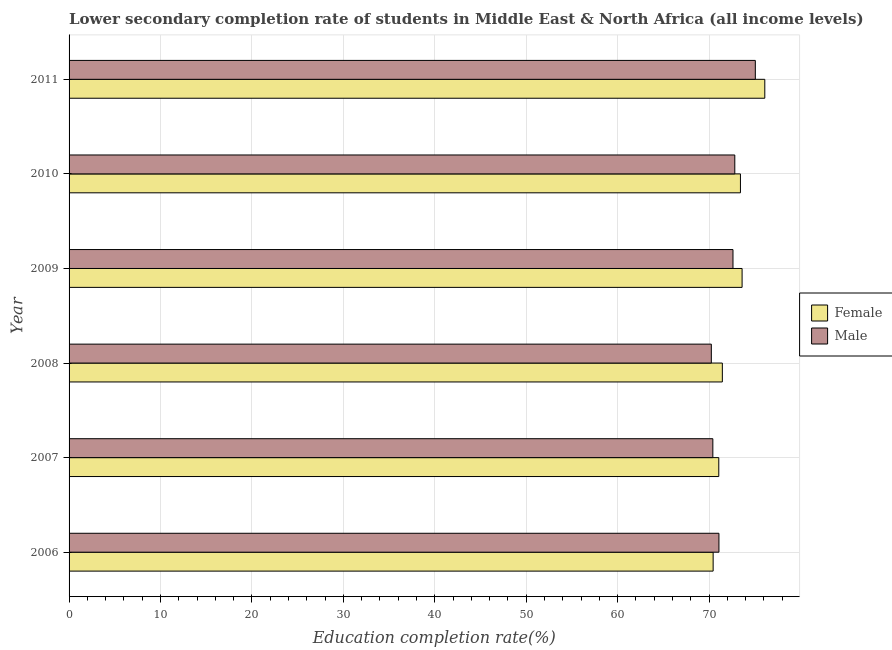How many different coloured bars are there?
Keep it short and to the point. 2. Are the number of bars per tick equal to the number of legend labels?
Make the answer very short. Yes. Are the number of bars on each tick of the Y-axis equal?
Offer a terse response. Yes. How many bars are there on the 3rd tick from the top?
Ensure brevity in your answer.  2. In how many cases, is the number of bars for a given year not equal to the number of legend labels?
Offer a very short reply. 0. What is the education completion rate of male students in 2009?
Make the answer very short. 72.62. Across all years, what is the maximum education completion rate of male students?
Offer a very short reply. 75.06. Across all years, what is the minimum education completion rate of female students?
Provide a succinct answer. 70.45. In which year was the education completion rate of female students maximum?
Give a very brief answer. 2011. What is the total education completion rate of female students in the graph?
Provide a short and direct response. 436.13. What is the difference between the education completion rate of male students in 2007 and that in 2011?
Your response must be concise. -4.65. What is the difference between the education completion rate of male students in 2008 and the education completion rate of female students in 2011?
Your answer should be compact. -5.85. What is the average education completion rate of female students per year?
Provide a short and direct response. 72.69. In the year 2011, what is the difference between the education completion rate of female students and education completion rate of male students?
Ensure brevity in your answer.  1.04. Is the education completion rate of male students in 2008 less than that in 2010?
Give a very brief answer. Yes. What is the difference between the highest and the second highest education completion rate of female students?
Ensure brevity in your answer.  2.48. What is the difference between the highest and the lowest education completion rate of female students?
Provide a succinct answer. 5.65. In how many years, is the education completion rate of female students greater than the average education completion rate of female students taken over all years?
Make the answer very short. 3. Is the sum of the education completion rate of female students in 2009 and 2011 greater than the maximum education completion rate of male students across all years?
Ensure brevity in your answer.  Yes. How many bars are there?
Keep it short and to the point. 12. Are all the bars in the graph horizontal?
Provide a short and direct response. Yes. Are the values on the major ticks of X-axis written in scientific E-notation?
Offer a terse response. No. Does the graph contain any zero values?
Make the answer very short. No. What is the title of the graph?
Keep it short and to the point. Lower secondary completion rate of students in Middle East & North Africa (all income levels). Does "Banks" appear as one of the legend labels in the graph?
Keep it short and to the point. No. What is the label or title of the X-axis?
Your answer should be very brief. Education completion rate(%). What is the Education completion rate(%) in Female in 2006?
Make the answer very short. 70.45. What is the Education completion rate(%) of Male in 2006?
Offer a very short reply. 71.08. What is the Education completion rate(%) in Female in 2007?
Provide a succinct answer. 71.07. What is the Education completion rate(%) of Male in 2007?
Ensure brevity in your answer.  70.42. What is the Education completion rate(%) of Female in 2008?
Offer a very short reply. 71.46. What is the Education completion rate(%) of Male in 2008?
Offer a terse response. 70.25. What is the Education completion rate(%) in Female in 2009?
Offer a very short reply. 73.62. What is the Education completion rate(%) of Male in 2009?
Your response must be concise. 72.62. What is the Education completion rate(%) in Female in 2010?
Your answer should be very brief. 73.44. What is the Education completion rate(%) of Male in 2010?
Offer a very short reply. 72.82. What is the Education completion rate(%) of Female in 2011?
Give a very brief answer. 76.1. What is the Education completion rate(%) in Male in 2011?
Offer a terse response. 75.06. Across all years, what is the maximum Education completion rate(%) of Female?
Your answer should be compact. 76.1. Across all years, what is the maximum Education completion rate(%) of Male?
Your response must be concise. 75.06. Across all years, what is the minimum Education completion rate(%) in Female?
Make the answer very short. 70.45. Across all years, what is the minimum Education completion rate(%) in Male?
Make the answer very short. 70.25. What is the total Education completion rate(%) of Female in the graph?
Keep it short and to the point. 436.13. What is the total Education completion rate(%) in Male in the graph?
Your answer should be compact. 432.26. What is the difference between the Education completion rate(%) in Female in 2006 and that in 2007?
Your answer should be very brief. -0.62. What is the difference between the Education completion rate(%) of Male in 2006 and that in 2007?
Give a very brief answer. 0.67. What is the difference between the Education completion rate(%) of Female in 2006 and that in 2008?
Keep it short and to the point. -1.01. What is the difference between the Education completion rate(%) of Male in 2006 and that in 2008?
Ensure brevity in your answer.  0.83. What is the difference between the Education completion rate(%) in Female in 2006 and that in 2009?
Your response must be concise. -3.17. What is the difference between the Education completion rate(%) of Male in 2006 and that in 2009?
Your response must be concise. -1.53. What is the difference between the Education completion rate(%) of Female in 2006 and that in 2010?
Offer a very short reply. -2.99. What is the difference between the Education completion rate(%) in Male in 2006 and that in 2010?
Give a very brief answer. -1.73. What is the difference between the Education completion rate(%) in Female in 2006 and that in 2011?
Make the answer very short. -5.65. What is the difference between the Education completion rate(%) of Male in 2006 and that in 2011?
Provide a succinct answer. -3.98. What is the difference between the Education completion rate(%) of Female in 2007 and that in 2008?
Keep it short and to the point. -0.39. What is the difference between the Education completion rate(%) in Male in 2007 and that in 2008?
Make the answer very short. 0.17. What is the difference between the Education completion rate(%) in Female in 2007 and that in 2009?
Keep it short and to the point. -2.55. What is the difference between the Education completion rate(%) of Male in 2007 and that in 2009?
Offer a very short reply. -2.2. What is the difference between the Education completion rate(%) of Female in 2007 and that in 2010?
Make the answer very short. -2.37. What is the difference between the Education completion rate(%) in Male in 2007 and that in 2010?
Your answer should be very brief. -2.4. What is the difference between the Education completion rate(%) in Female in 2007 and that in 2011?
Ensure brevity in your answer.  -5.03. What is the difference between the Education completion rate(%) of Male in 2007 and that in 2011?
Ensure brevity in your answer.  -4.65. What is the difference between the Education completion rate(%) in Female in 2008 and that in 2009?
Provide a succinct answer. -2.16. What is the difference between the Education completion rate(%) of Male in 2008 and that in 2009?
Give a very brief answer. -2.37. What is the difference between the Education completion rate(%) in Female in 2008 and that in 2010?
Your answer should be very brief. -1.98. What is the difference between the Education completion rate(%) of Male in 2008 and that in 2010?
Your answer should be compact. -2.57. What is the difference between the Education completion rate(%) in Female in 2008 and that in 2011?
Ensure brevity in your answer.  -4.64. What is the difference between the Education completion rate(%) of Male in 2008 and that in 2011?
Keep it short and to the point. -4.81. What is the difference between the Education completion rate(%) of Female in 2009 and that in 2010?
Your answer should be very brief. 0.18. What is the difference between the Education completion rate(%) in Male in 2009 and that in 2010?
Ensure brevity in your answer.  -0.2. What is the difference between the Education completion rate(%) in Female in 2009 and that in 2011?
Provide a short and direct response. -2.48. What is the difference between the Education completion rate(%) in Male in 2009 and that in 2011?
Provide a succinct answer. -2.44. What is the difference between the Education completion rate(%) in Female in 2010 and that in 2011?
Give a very brief answer. -2.66. What is the difference between the Education completion rate(%) of Male in 2010 and that in 2011?
Your response must be concise. -2.25. What is the difference between the Education completion rate(%) in Female in 2006 and the Education completion rate(%) in Male in 2007?
Make the answer very short. 0.03. What is the difference between the Education completion rate(%) of Female in 2006 and the Education completion rate(%) of Male in 2008?
Provide a succinct answer. 0.2. What is the difference between the Education completion rate(%) in Female in 2006 and the Education completion rate(%) in Male in 2009?
Your answer should be very brief. -2.17. What is the difference between the Education completion rate(%) in Female in 2006 and the Education completion rate(%) in Male in 2010?
Give a very brief answer. -2.37. What is the difference between the Education completion rate(%) of Female in 2006 and the Education completion rate(%) of Male in 2011?
Give a very brief answer. -4.61. What is the difference between the Education completion rate(%) of Female in 2007 and the Education completion rate(%) of Male in 2008?
Provide a short and direct response. 0.82. What is the difference between the Education completion rate(%) of Female in 2007 and the Education completion rate(%) of Male in 2009?
Offer a very short reply. -1.55. What is the difference between the Education completion rate(%) of Female in 2007 and the Education completion rate(%) of Male in 2010?
Your answer should be very brief. -1.75. What is the difference between the Education completion rate(%) of Female in 2007 and the Education completion rate(%) of Male in 2011?
Ensure brevity in your answer.  -4. What is the difference between the Education completion rate(%) of Female in 2008 and the Education completion rate(%) of Male in 2009?
Your answer should be very brief. -1.16. What is the difference between the Education completion rate(%) of Female in 2008 and the Education completion rate(%) of Male in 2010?
Make the answer very short. -1.36. What is the difference between the Education completion rate(%) in Female in 2008 and the Education completion rate(%) in Male in 2011?
Provide a succinct answer. -3.61. What is the difference between the Education completion rate(%) of Female in 2009 and the Education completion rate(%) of Male in 2010?
Your response must be concise. 0.8. What is the difference between the Education completion rate(%) of Female in 2009 and the Education completion rate(%) of Male in 2011?
Your answer should be compact. -1.45. What is the difference between the Education completion rate(%) in Female in 2010 and the Education completion rate(%) in Male in 2011?
Make the answer very short. -1.63. What is the average Education completion rate(%) in Female per year?
Offer a terse response. 72.69. What is the average Education completion rate(%) in Male per year?
Offer a very short reply. 72.04. In the year 2006, what is the difference between the Education completion rate(%) in Female and Education completion rate(%) in Male?
Provide a succinct answer. -0.63. In the year 2007, what is the difference between the Education completion rate(%) in Female and Education completion rate(%) in Male?
Ensure brevity in your answer.  0.65. In the year 2008, what is the difference between the Education completion rate(%) of Female and Education completion rate(%) of Male?
Make the answer very short. 1.21. In the year 2010, what is the difference between the Education completion rate(%) in Female and Education completion rate(%) in Male?
Ensure brevity in your answer.  0.62. In the year 2011, what is the difference between the Education completion rate(%) in Female and Education completion rate(%) in Male?
Give a very brief answer. 1.04. What is the ratio of the Education completion rate(%) of Female in 2006 to that in 2007?
Make the answer very short. 0.99. What is the ratio of the Education completion rate(%) of Male in 2006 to that in 2007?
Offer a terse response. 1.01. What is the ratio of the Education completion rate(%) in Female in 2006 to that in 2008?
Give a very brief answer. 0.99. What is the ratio of the Education completion rate(%) of Male in 2006 to that in 2008?
Give a very brief answer. 1.01. What is the ratio of the Education completion rate(%) of Male in 2006 to that in 2009?
Provide a succinct answer. 0.98. What is the ratio of the Education completion rate(%) in Female in 2006 to that in 2010?
Keep it short and to the point. 0.96. What is the ratio of the Education completion rate(%) in Male in 2006 to that in 2010?
Make the answer very short. 0.98. What is the ratio of the Education completion rate(%) of Female in 2006 to that in 2011?
Give a very brief answer. 0.93. What is the ratio of the Education completion rate(%) of Male in 2006 to that in 2011?
Ensure brevity in your answer.  0.95. What is the ratio of the Education completion rate(%) of Female in 2007 to that in 2008?
Give a very brief answer. 0.99. What is the ratio of the Education completion rate(%) in Female in 2007 to that in 2009?
Offer a very short reply. 0.97. What is the ratio of the Education completion rate(%) in Male in 2007 to that in 2009?
Provide a succinct answer. 0.97. What is the ratio of the Education completion rate(%) of Female in 2007 to that in 2010?
Offer a very short reply. 0.97. What is the ratio of the Education completion rate(%) of Female in 2007 to that in 2011?
Your answer should be very brief. 0.93. What is the ratio of the Education completion rate(%) of Male in 2007 to that in 2011?
Provide a short and direct response. 0.94. What is the ratio of the Education completion rate(%) of Female in 2008 to that in 2009?
Your answer should be compact. 0.97. What is the ratio of the Education completion rate(%) in Male in 2008 to that in 2009?
Provide a succinct answer. 0.97. What is the ratio of the Education completion rate(%) of Male in 2008 to that in 2010?
Offer a very short reply. 0.96. What is the ratio of the Education completion rate(%) in Female in 2008 to that in 2011?
Offer a very short reply. 0.94. What is the ratio of the Education completion rate(%) in Male in 2008 to that in 2011?
Make the answer very short. 0.94. What is the ratio of the Education completion rate(%) in Female in 2009 to that in 2011?
Provide a succinct answer. 0.97. What is the ratio of the Education completion rate(%) in Male in 2009 to that in 2011?
Provide a short and direct response. 0.97. What is the ratio of the Education completion rate(%) of Female in 2010 to that in 2011?
Offer a terse response. 0.96. What is the ratio of the Education completion rate(%) of Male in 2010 to that in 2011?
Offer a very short reply. 0.97. What is the difference between the highest and the second highest Education completion rate(%) in Female?
Provide a short and direct response. 2.48. What is the difference between the highest and the second highest Education completion rate(%) of Male?
Keep it short and to the point. 2.25. What is the difference between the highest and the lowest Education completion rate(%) of Female?
Give a very brief answer. 5.65. What is the difference between the highest and the lowest Education completion rate(%) of Male?
Make the answer very short. 4.81. 